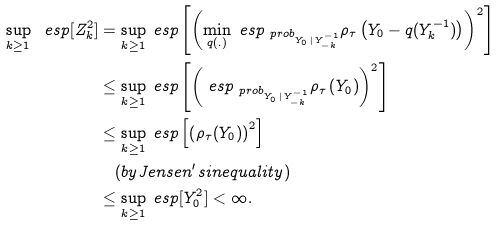<formula> <loc_0><loc_0><loc_500><loc_500>\sup _ { k \geq 1 } \ e s p [ Z _ { k } ^ { 2 } ] & = \sup _ { k \geq 1 } \ e s p \left [ \left ( \min _ { q ( . ) } \ e s p _ { \ p r o b _ { Y _ { 0 } \, | \, Y _ { - k } ^ { - 1 } } } \rho _ { \tau } \left ( Y _ { 0 } - q ( Y _ { k } ^ { - 1 } ) \right ) \right ) ^ { 2 } \right ] \\ & \leq \sup _ { k \geq 1 } \ e s p \left [ \left ( \ e s p _ { \ p r o b _ { Y _ { 0 } \, | \, Y _ { - k } ^ { - 1 } } } \rho _ { \tau } \left ( Y _ { 0 } \right ) \right ) ^ { 2 } \right ] \\ & \leq \sup _ { k \geq 1 } \ e s p \left [ \left ( \rho _ { \tau } ( Y _ { 0 } ) \right ) ^ { 2 } \right ] \\ & \quad ( b y J e n s e n ^ { \prime } s i n e q u a l i t y ) \\ & \leq \sup _ { k \geq 1 } \ e s p [ Y _ { 0 } ^ { 2 } ] < \infty .</formula> 